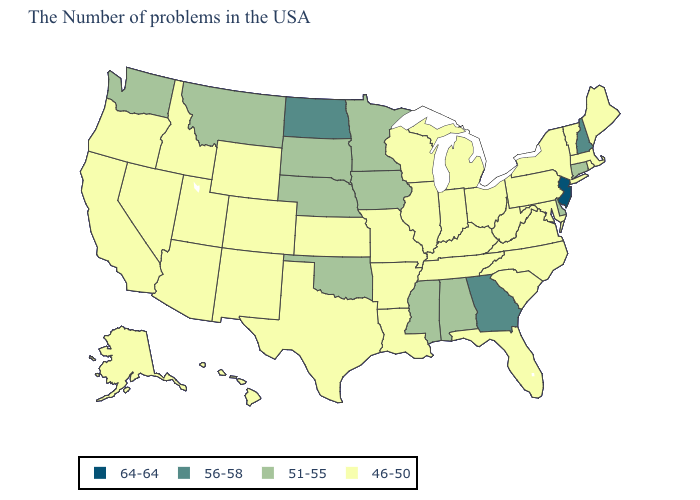How many symbols are there in the legend?
Write a very short answer. 4. What is the lowest value in states that border Idaho?
Write a very short answer. 46-50. What is the lowest value in the USA?
Keep it brief. 46-50. Among the states that border Washington , which have the lowest value?
Give a very brief answer. Idaho, Oregon. How many symbols are there in the legend?
Give a very brief answer. 4. Does Washington have the lowest value in the West?
Short answer required. No. What is the highest value in states that border Tennessee?
Give a very brief answer. 56-58. What is the highest value in the USA?
Write a very short answer. 64-64. Does Kentucky have the same value as Georgia?
Short answer required. No. Name the states that have a value in the range 51-55?
Write a very short answer. Connecticut, Delaware, Alabama, Mississippi, Minnesota, Iowa, Nebraska, Oklahoma, South Dakota, Montana, Washington. Name the states that have a value in the range 51-55?
Answer briefly. Connecticut, Delaware, Alabama, Mississippi, Minnesota, Iowa, Nebraska, Oklahoma, South Dakota, Montana, Washington. Name the states that have a value in the range 46-50?
Short answer required. Maine, Massachusetts, Rhode Island, Vermont, New York, Maryland, Pennsylvania, Virginia, North Carolina, South Carolina, West Virginia, Ohio, Florida, Michigan, Kentucky, Indiana, Tennessee, Wisconsin, Illinois, Louisiana, Missouri, Arkansas, Kansas, Texas, Wyoming, Colorado, New Mexico, Utah, Arizona, Idaho, Nevada, California, Oregon, Alaska, Hawaii. What is the value of South Carolina?
Be succinct. 46-50. How many symbols are there in the legend?
Quick response, please. 4. Among the states that border New Mexico , does Oklahoma have the highest value?
Quick response, please. Yes. 